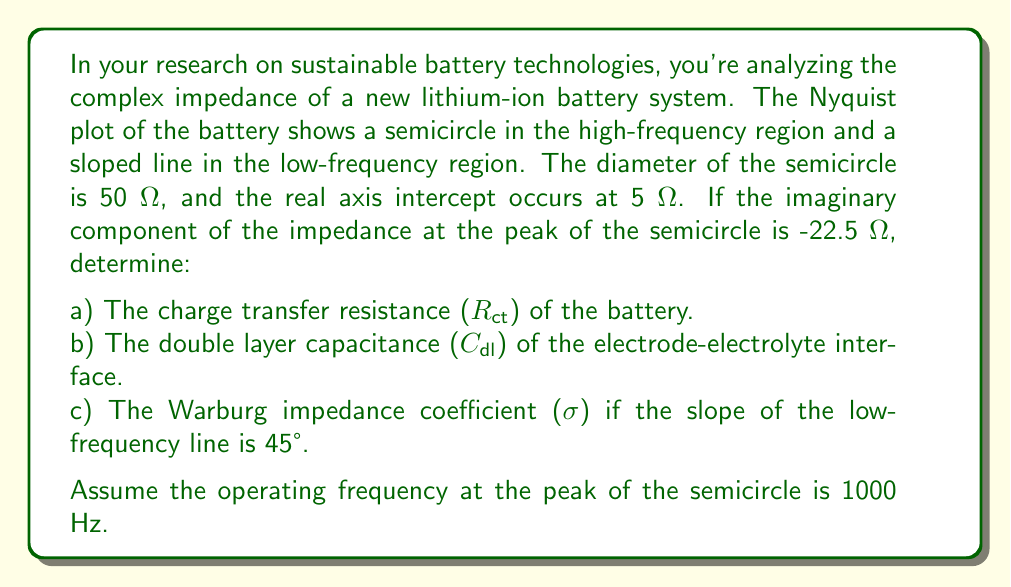Teach me how to tackle this problem. Let's approach this problem step-by-step:

a) The charge transfer resistance (R_ct) is represented by the diameter of the semicircle in the Nyquist plot. Therefore:

   R_ct = 50 Ω

b) To find the double layer capacitance (C_dl), we need to use the relationship between R_ct, C_dl, and the frequency at the peak of the semicircle. At the peak, the following equation holds:

   $$ \omega_{peak} = \frac{1}{R_{ct}C_{dl}} $$

   Where $\omega_{peak} = 2\pi f_{peak}$

   We're given that $f_{peak} = 1000$ Hz, so:

   $$ 2\pi(1000) = \frac{1}{50C_{dl}} $$

   Solving for C_dl:

   $$ C_{dl} = \frac{1}{2\pi(1000)(50)} = 3.18 \times 10^{-6} \text{ F} = 3.18 \text{ µF} $$

c) The Warburg impedance coefficient (σ) can be determined from the low-frequency region of the Nyquist plot. When the slope is 45°, the real and imaginary parts of the Warburg impedance are equal:

   $$ Z_W = \sigma\omega^{-1/2}(1-j) $$

   To find σ, we need to use the relationship between the imaginary part of the impedance at the peak of the semicircle and R_ct:

   $$ -Im(Z)_{peak} = \frac{R_{ct}}{2} $$

   We're given that $-Im(Z)_{peak} = 22.5$ Ω, which confirms our earlier calculation of R_ct:

   $$ 22.5 = \frac{50}{2} $$

   The real axis intercept (5 Ω) represents the solution resistance (R_s). The distance from this intercept to the start of the Warburg region is R_ct. Therefore, the Warburg impedance begins at:

   $$ R_s + R_{ct} = 5 + 50 = 55 \text{ Ω} $$

   At this point, the real and imaginary parts of the Warburg impedance are equal. We can use this to find σ:

   $$ \sigma\omega^{-1/2} = 55 - 5 = 50 \text{ Ω} $$

   $$ \sigma = 50 \cdot (2\pi \cdot 1000)^{1/2} = 3960 \text{ Ω} \cdot \text{s}^{-1/2} $$
Answer: a) R_ct = 50 Ω
b) C_dl = 3.18 µF
c) σ = 3960 Ω·s^(-1/2) 